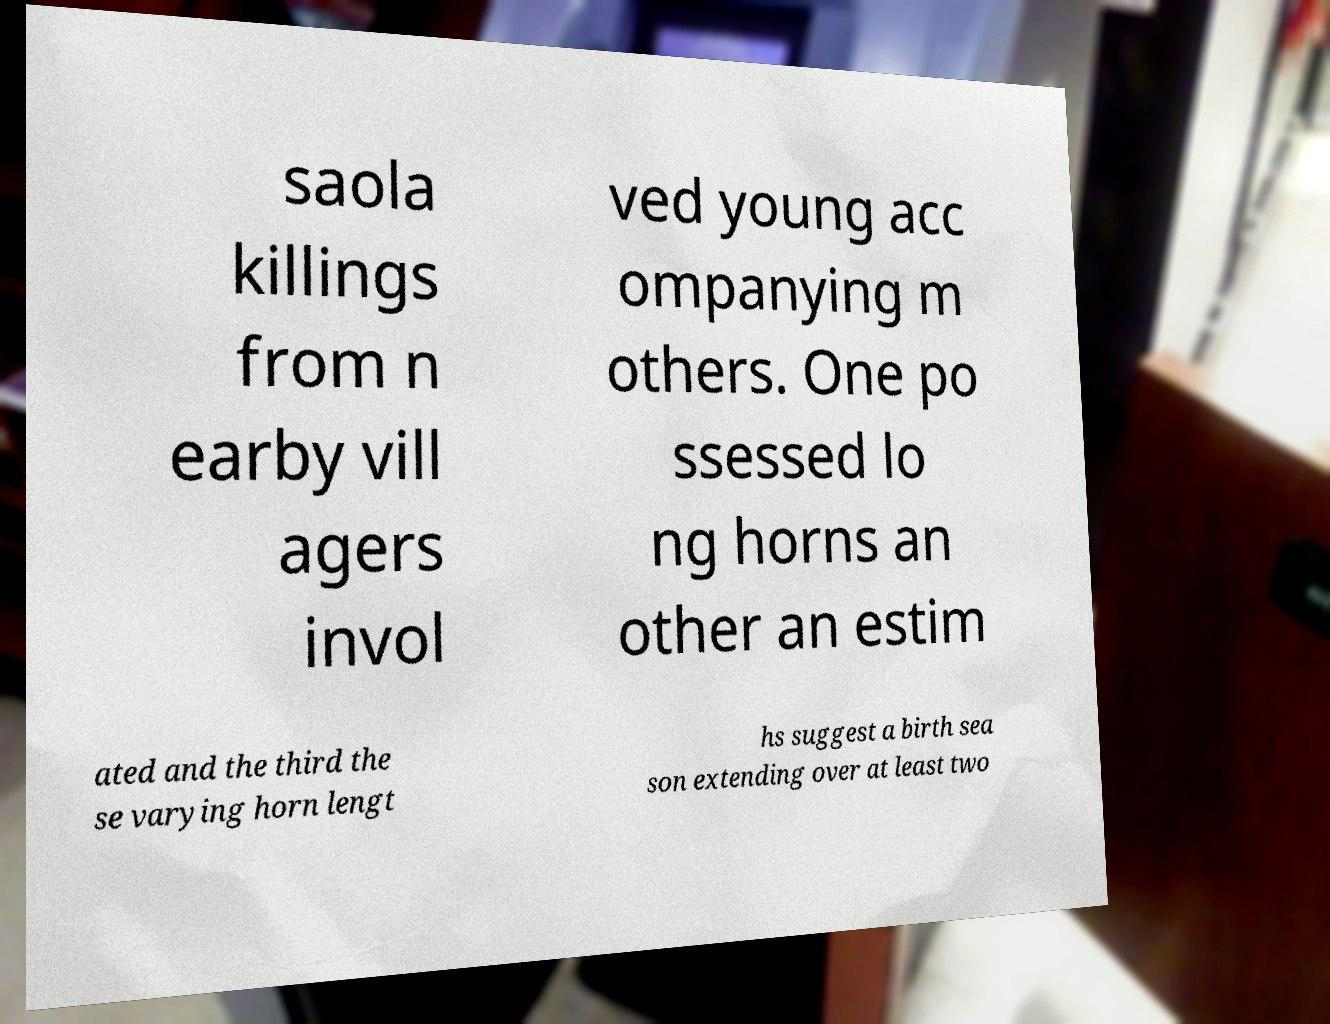Can you read and provide the text displayed in the image?This photo seems to have some interesting text. Can you extract and type it out for me? saola killings from n earby vill agers invol ved young acc ompanying m others. One po ssessed lo ng horns an other an estim ated and the third the se varying horn lengt hs suggest a birth sea son extending over at least two 